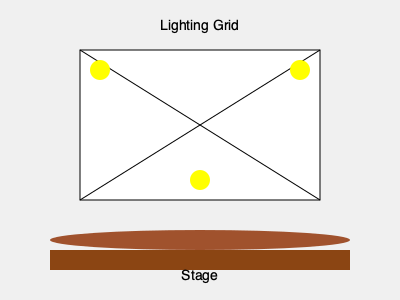In the lighting design layout shown above, what type of lighting arrangement is depicted by the three yellow circles, and how might this setup enhance a performance? To answer this question, let's analyze the lighting design layout step-by-step:

1. Observe the diagram: We see a stage represented by the brown rectangle and ellipse at the bottom, with a lighting grid above it.

2. Identify the lighting arrangement: There are three yellow circles positioned in a triangular formation within the lighting grid.

3. Recognize the lighting technique: This arrangement is known as "three-point lighting," a fundamental technique in stage and film lighting.

4. Understand the components of three-point lighting:
   a. Key light: Usually the strongest and most prominent light, often placed to one side of the subject.
   b. Fill light: Softer light placed opposite the key light to fill in shadows.
   c. Back light: Positioned behind and above the subject to create separation from the background.

5. Consider the benefits of this setup:
   - It provides dimensional lighting, creating depth and reducing flat appearances.
   - It allows for control over shadows and highlights, enhancing the visual appeal of performers or set pieces.
   - It can be adjusted to create different moods or emphasize specific areas of the stage.

6. Application to performance:
   - This setup can be used to highlight lead actors, important props, or specific areas of the stage.
   - It allows for dynamic lighting changes during scenes, enhancing the dramatic effect.
   - It provides flexibility for various types of performances, from plays to musical acts.
Answer: Three-point lighting; enhances depth, control, and visual appeal 